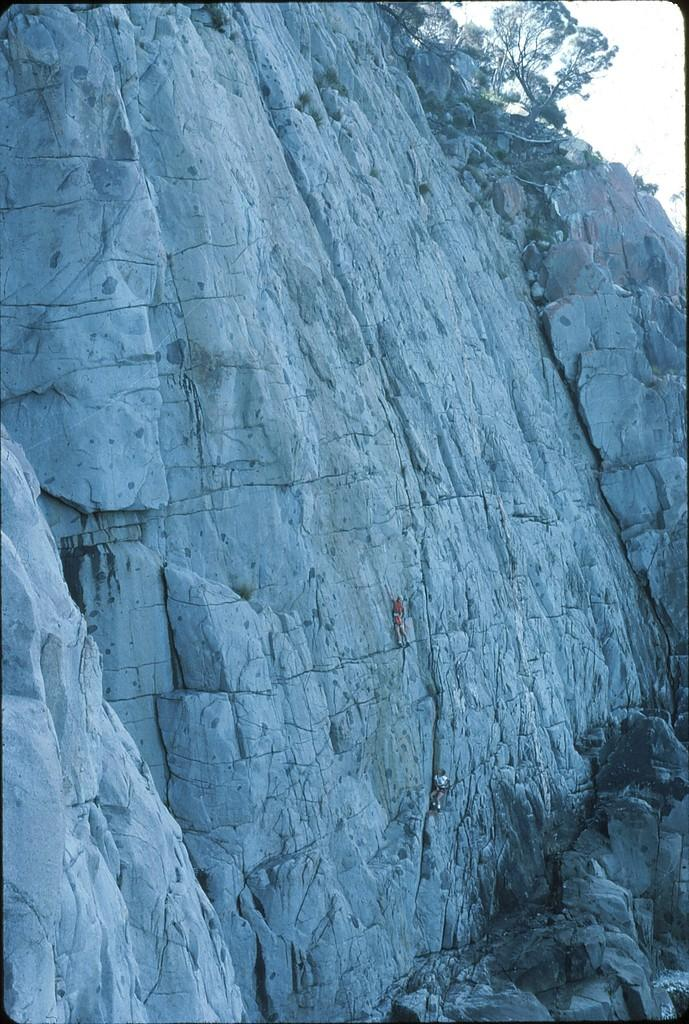What is in the foreground of the image? There are rocks in the foreground of the image. What are the two persons in the image doing? The two persons are climbing the rocks. What can be seen on top of the rocks? There is a tree on the top of the rocks. What is visible in the background of the image? The sky is visible in the image. What type of sail can be seen in the image? There is no sail present in the image; it features rocks, two persons climbing, a tree on top, and the sky. What color is the yarn used to decorate the frame in the image? There is no frame or yarn present in the image. 